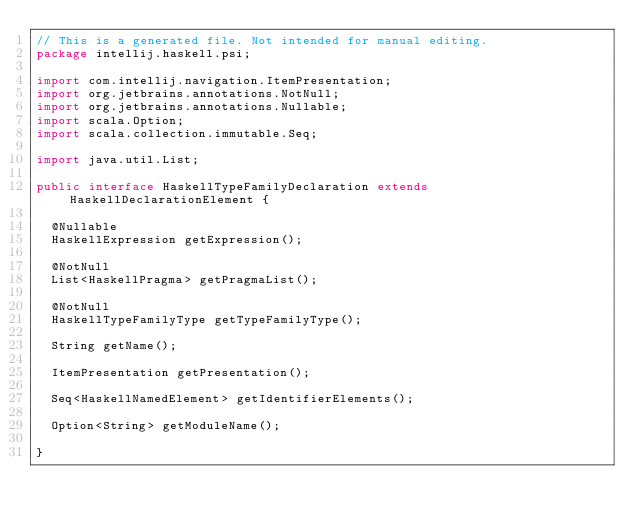Convert code to text. <code><loc_0><loc_0><loc_500><loc_500><_Java_>// This is a generated file. Not intended for manual editing.
package intellij.haskell.psi;

import com.intellij.navigation.ItemPresentation;
import org.jetbrains.annotations.NotNull;
import org.jetbrains.annotations.Nullable;
import scala.Option;
import scala.collection.immutable.Seq;

import java.util.List;

public interface HaskellTypeFamilyDeclaration extends HaskellDeclarationElement {

  @Nullable
  HaskellExpression getExpression();

  @NotNull
  List<HaskellPragma> getPragmaList();

  @NotNull
  HaskellTypeFamilyType getTypeFamilyType();

  String getName();

  ItemPresentation getPresentation();

  Seq<HaskellNamedElement> getIdentifierElements();

  Option<String> getModuleName();

}
</code> 